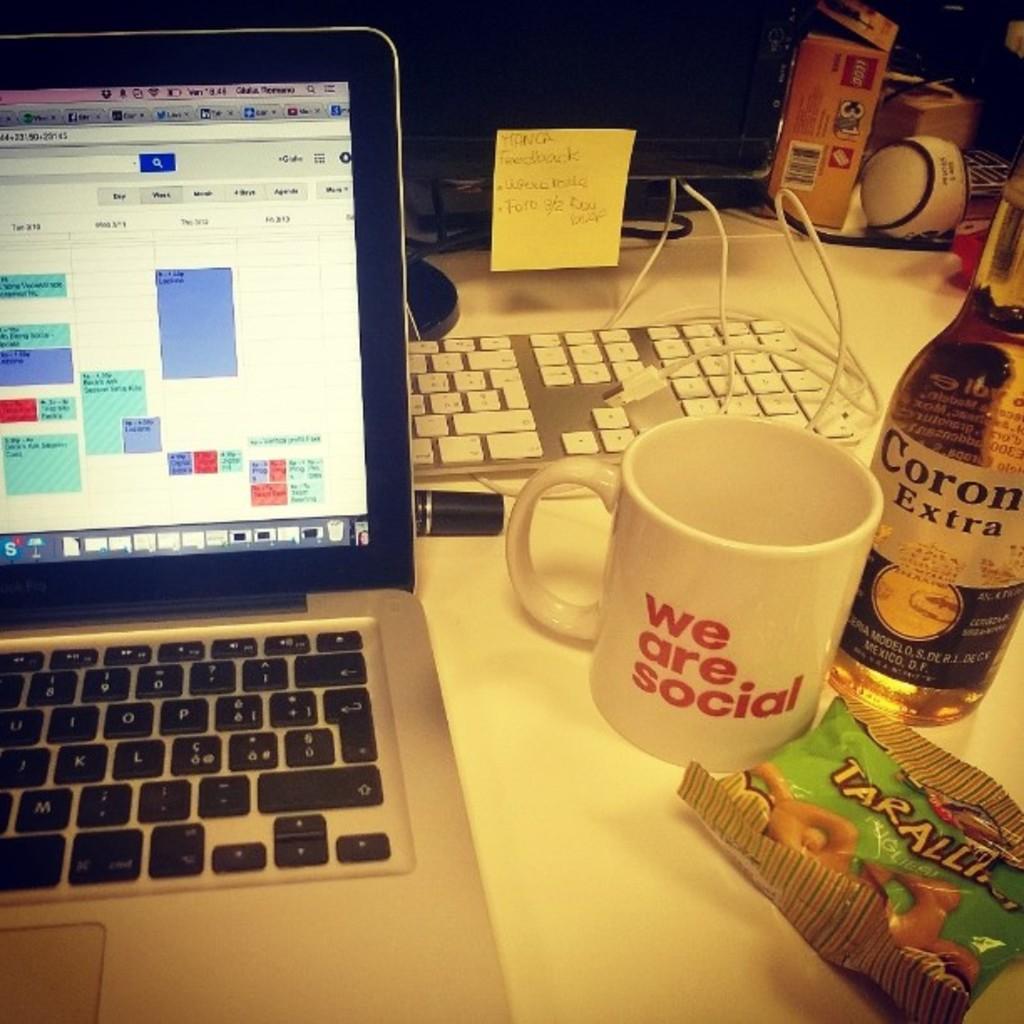Describe this image in one or two sentences. This photo is of a table. on the table there is a laptop,mug,bottle,food packet,keyboard,monitor on the monitor a sticky note is stick. There is a ball, a packet and many other things are present. 